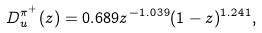<formula> <loc_0><loc_0><loc_500><loc_500>D _ { u } ^ { \pi ^ { + } } ( z ) = 0 . 6 8 9 z ^ { - 1 . 0 3 9 } ( 1 - z ) ^ { 1 . 2 4 1 } ,</formula> 